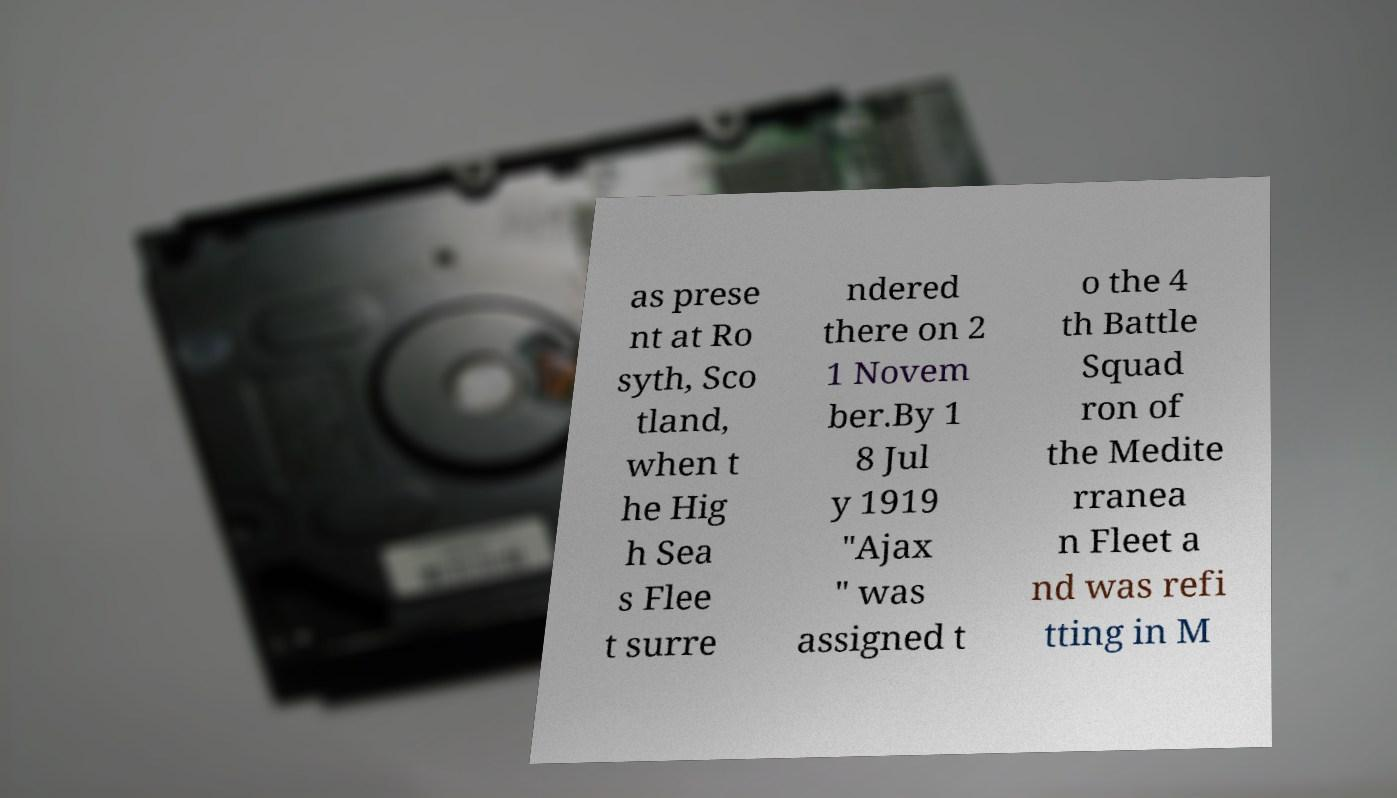Please identify and transcribe the text found in this image. as prese nt at Ro syth, Sco tland, when t he Hig h Sea s Flee t surre ndered there on 2 1 Novem ber.By 1 8 Jul y 1919 "Ajax " was assigned t o the 4 th Battle Squad ron of the Medite rranea n Fleet a nd was refi tting in M 